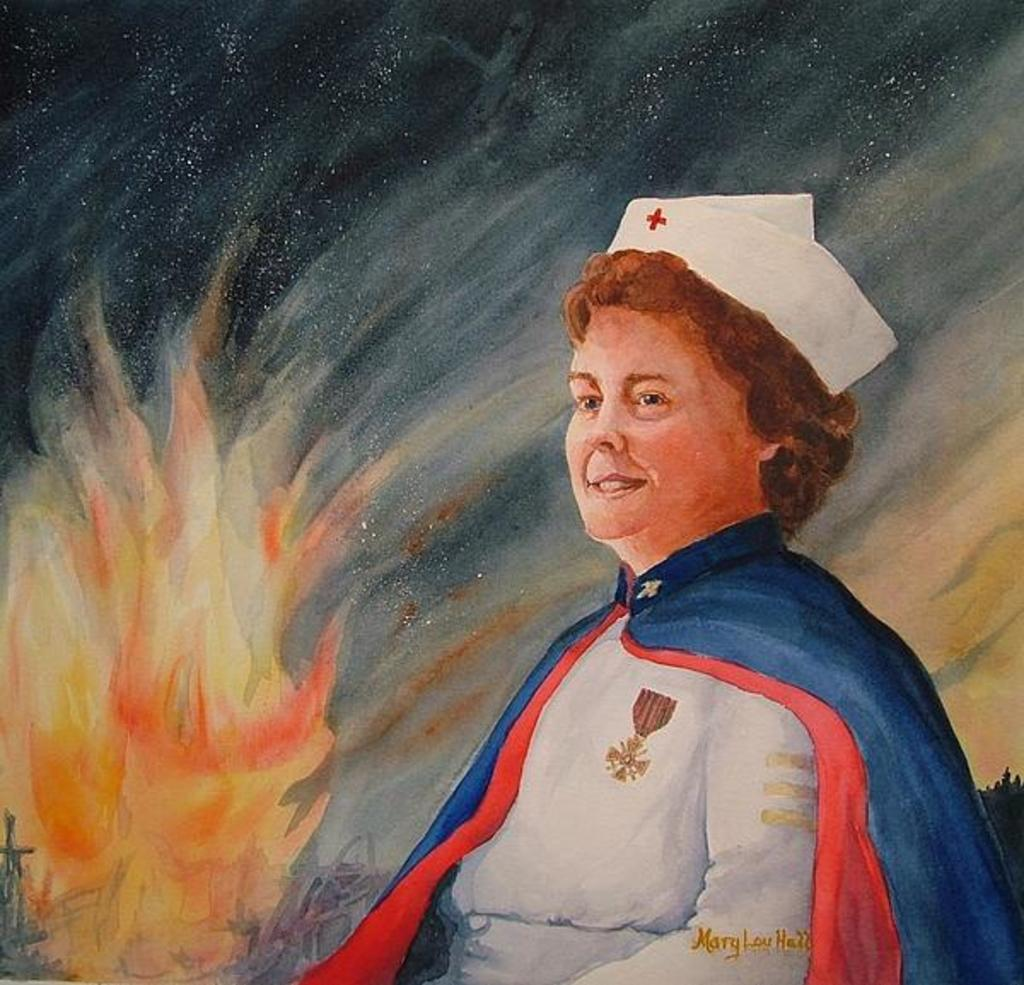What is depicted in the picture? There is an image of a person and a flame in the picture. Can you describe the background in the picture? There is a background visible in the picture. What type of curtain can be seen in the image? There is no curtain present in the image. What bookshelves can be seen in the image? There is no library or bookshelves present in the image. 